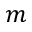Convert formula to latex. <formula><loc_0><loc_0><loc_500><loc_500>m</formula> 